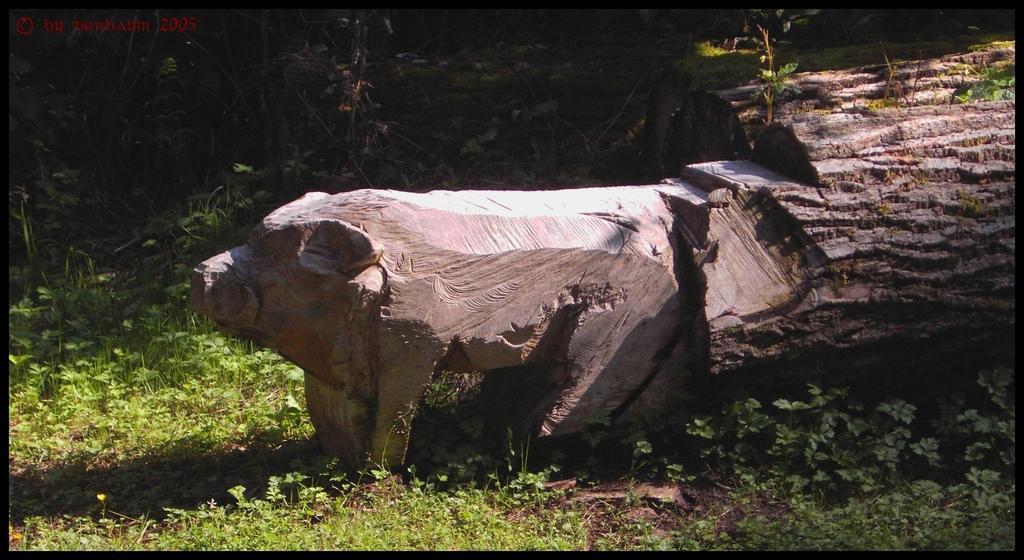In one or two sentences, can you explain what this image depicts? This looks like a wooden tree trunk, which is carved. Here is the grass. In the background, I can see the trees. This looks like a watermark on the image. 